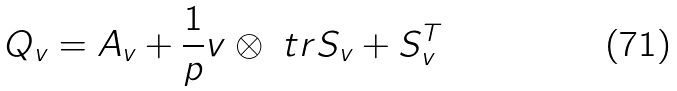<formula> <loc_0><loc_0><loc_500><loc_500>Q _ { v } = A _ { v } + \frac { 1 } { p } v \otimes \ t r S _ { v } + S _ { v } ^ { T }</formula> 